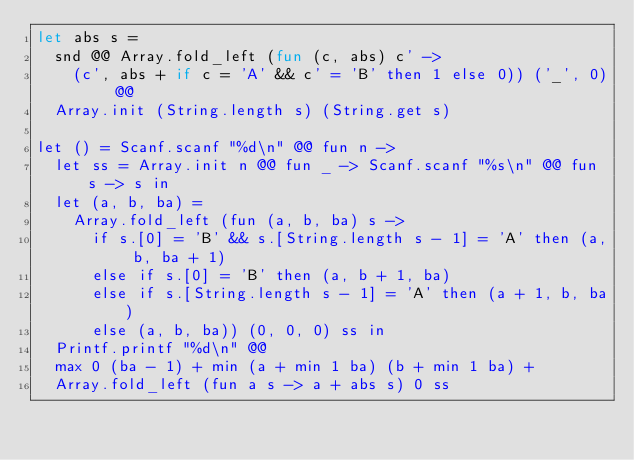<code> <loc_0><loc_0><loc_500><loc_500><_OCaml_>let abs s =
  snd @@ Array.fold_left (fun (c, abs) c' ->
    (c', abs + if c = 'A' && c' = 'B' then 1 else 0)) ('_', 0) @@
  Array.init (String.length s) (String.get s)

let () = Scanf.scanf "%d\n" @@ fun n ->
  let ss = Array.init n @@ fun _ -> Scanf.scanf "%s\n" @@ fun s -> s in
  let (a, b, ba) =
    Array.fold_left (fun (a, b, ba) s ->
      if s.[0] = 'B' && s.[String.length s - 1] = 'A' then (a, b, ba + 1)
      else if s.[0] = 'B' then (a, b + 1, ba)
      else if s.[String.length s - 1] = 'A' then (a + 1, b, ba)
      else (a, b, ba)) (0, 0, 0) ss in
  Printf.printf "%d\n" @@
  max 0 (ba - 1) + min (a + min 1 ba) (b + min 1 ba) +
  Array.fold_left (fun a s -> a + abs s) 0 ss</code> 